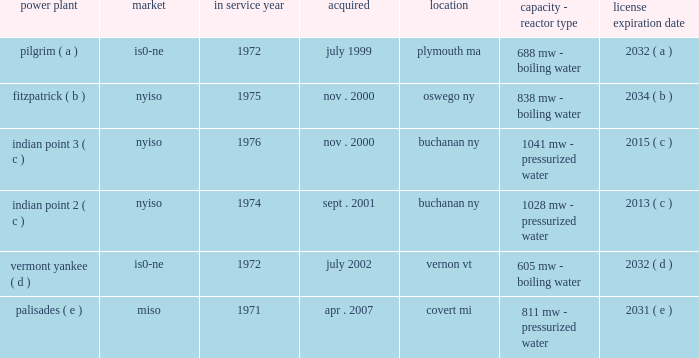Part i item 1 entergy corporation , utility operating companies , and system energy including the continued effectiveness of the clean energy standards/zero emissions credit program ( ces/zec ) , the establishment of certain long-term agreements on acceptable terms with the energy research and development authority of the state of new york in connection with the ces/zec program , and nypsc approval of the transaction on acceptable terms , entergy refueled the fitzpatrick plant in january and february 2017 .
In october 2015 , entergy determined that it would close the pilgrim plant .
The decision came after management 2019s extensive analysis of the economics and operating life of the plant following the nrc 2019s decision in september 2015 to place the plant in its 201cmultiple/repetitive degraded cornerstone column 201d ( column 4 ) of its reactor oversight process action matrix .
The pilgrim plant is expected to cease operations on may 31 , 2019 , after refueling in the spring of 2017 and operating through the end of that fuel cycle .
In december 2015 , entergy wholesale commodities closed on the sale of its 583 mw rhode island state energy center ( risec ) , in johnston , rhode island .
The base sales price , excluding adjustments , was approximately $ 490 million .
Entergy wholesale commodities purchased risec for $ 346 million in december 2011 .
In december 2016 , entergy announced that it reached an agreement with consumers energy to terminate the ppa for the palisades plant on may 31 , 2018 .
Pursuant to the ppa termination agreement , consumers energy will pay entergy $ 172 million for the early termination of the ppa .
The ppa termination agreement is subject to regulatory approvals .
Separately , and assuming regulatory approvals are obtained for the ppa termination agreement , entergy intends to shut down the palisades nuclear power plant permanently on october 1 , 2018 , after refueling in the spring of 2017 and operating through the end of that fuel cycle .
Entergy expects to enter into a new ppa with consumers energy under which the plant would continue to operate through october 1 , 2018 .
In january 2017 , entergy announced that it reached a settlement with new york state to shut down indian point 2 by april 30 , 2020 and indian point 3 by april 30 , 2021 , and resolve all new york state-initiated legal challenges to indian point 2019s operating license renewal .
As part of the settlement , new york state has agreed to issue indian point 2019s water quality certification and coastal zone management act consistency certification and to withdraw its objection to license renewal before the nrc .
New york state also has agreed to issue a water discharge permit , which is required regardless of whether the plant is seeking a renewed nrc license .
The shutdowns are conditioned , among other things , upon such actions being taken by new york state .
Even without opposition , the nrc license renewal process is expected to continue at least into 2018 .
With the settlement concerning indian point , entergy now has announced plans for the disposition of all of the entergy wholesale commodities nuclear power plants , including the sales of vermont yankee and fitzpatrick , and the earlier than previously expected shutdowns of pilgrim , palisades , indian point 2 , and indian point 3 .
See 201centergy wholesale commodities exit from the merchant power business 201d for further discussion .
Property nuclear generating stations entergy wholesale commodities includes the ownership of the following nuclear power plants : power plant market service year acquired location capacity - reactor type license expiration .

For how many years will entergy corporation run the indian point 2 power plant? 
Computations: (2015 - 2000)
Answer: 15.0. 